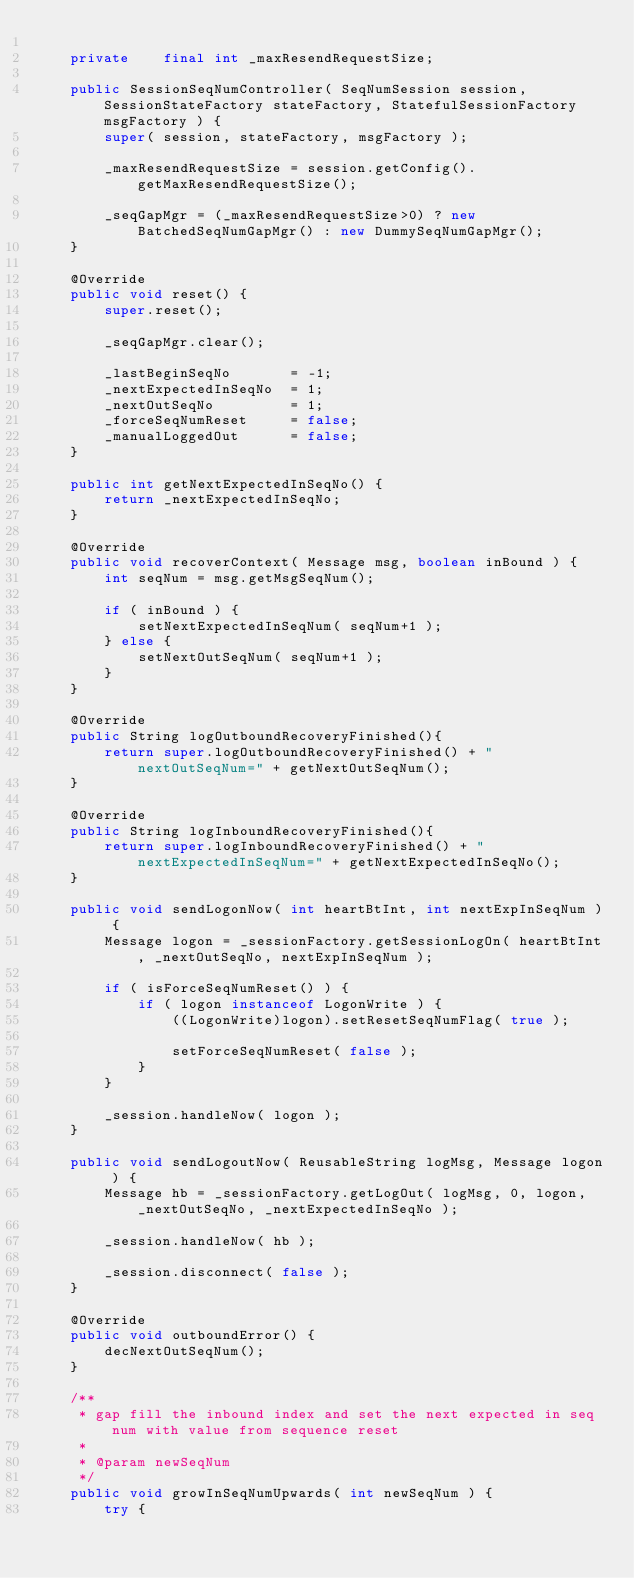Convert code to text. <code><loc_0><loc_0><loc_500><loc_500><_Java_>
    private    final int _maxResendRequestSize;

    public SessionSeqNumController( SeqNumSession session, SessionStateFactory stateFactory, StatefulSessionFactory msgFactory ) {
        super( session, stateFactory, msgFactory );
        
        _maxResendRequestSize = session.getConfig().getMaxResendRequestSize();
        
        _seqGapMgr = (_maxResendRequestSize>0) ? new BatchedSeqNumGapMgr() : new DummySeqNumGapMgr();
    }

    @Override
    public void reset() {
        super.reset();
        
        _seqGapMgr.clear();
        
        _lastBeginSeqNo       = -1;
        _nextExpectedInSeqNo  = 1;
        _nextOutSeqNo         = 1;
        _forceSeqNumReset     = false;
        _manualLoggedOut      = false;
    }
    
    public int getNextExpectedInSeqNo() {
        return _nextExpectedInSeqNo;
    }

    @Override
    public void recoverContext( Message msg, boolean inBound ) {
        int seqNum = msg.getMsgSeqNum();

        if ( inBound ) {
            setNextExpectedInSeqNum( seqNum+1 );
        } else {
            setNextOutSeqNum( seqNum+1 );
        }
    }

    @Override
    public String logOutboundRecoveryFinished(){
        return super.logOutboundRecoveryFinished() + " nextOutSeqNum=" + getNextOutSeqNum();
    }
    
    @Override
    public String logInboundRecoveryFinished(){
        return super.logInboundRecoveryFinished() + " nextExpectedInSeqNum=" + getNextExpectedInSeqNo();
    }
    
    public void sendLogonNow( int heartBtInt, int nextExpInSeqNum ) {
        Message logon = _sessionFactory.getSessionLogOn( heartBtInt, _nextOutSeqNo, nextExpInSeqNum );
        
        if ( isForceSeqNumReset() ) {
            if ( logon instanceof LogonWrite ) {
                ((LogonWrite)logon).setResetSeqNumFlag( true );
                
                setForceSeqNumReset( false );
            }
        }
        
        _session.handleNow( logon );
    }
    
    public void sendLogoutNow( ReusableString logMsg, Message logon ) {
        Message hb = _sessionFactory.getLogOut( logMsg, 0, logon, _nextOutSeqNo, _nextExpectedInSeqNo );
        
        _session.handleNow( hb );
        
        _session.disconnect( false );
    }

    @Override
    public void outboundError() {
        decNextOutSeqNum();        
    }
    
    /**
     * gap fill the inbound index and set the next expected in seq num with value from sequence reset
     *  
     * @param newSeqNum
     */
    public void growInSeqNumUpwards( int newSeqNum ) {
        try {</code> 